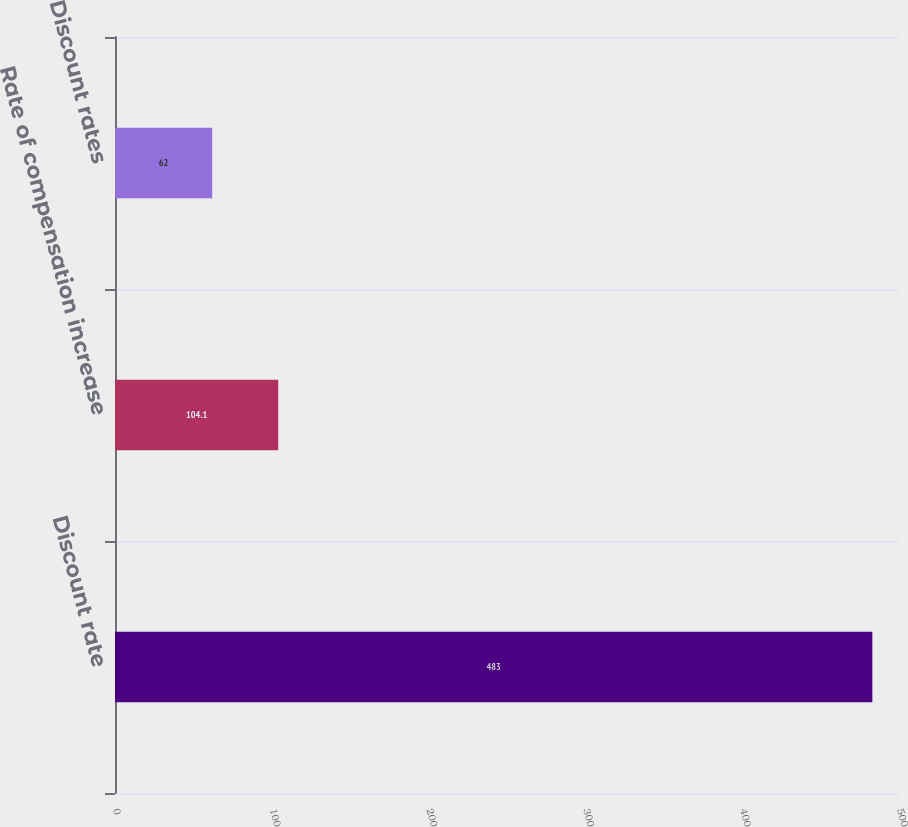Convert chart. <chart><loc_0><loc_0><loc_500><loc_500><bar_chart><fcel>Discount rate<fcel>Rate of compensation increase<fcel>Discount rates<nl><fcel>483<fcel>104.1<fcel>62<nl></chart> 